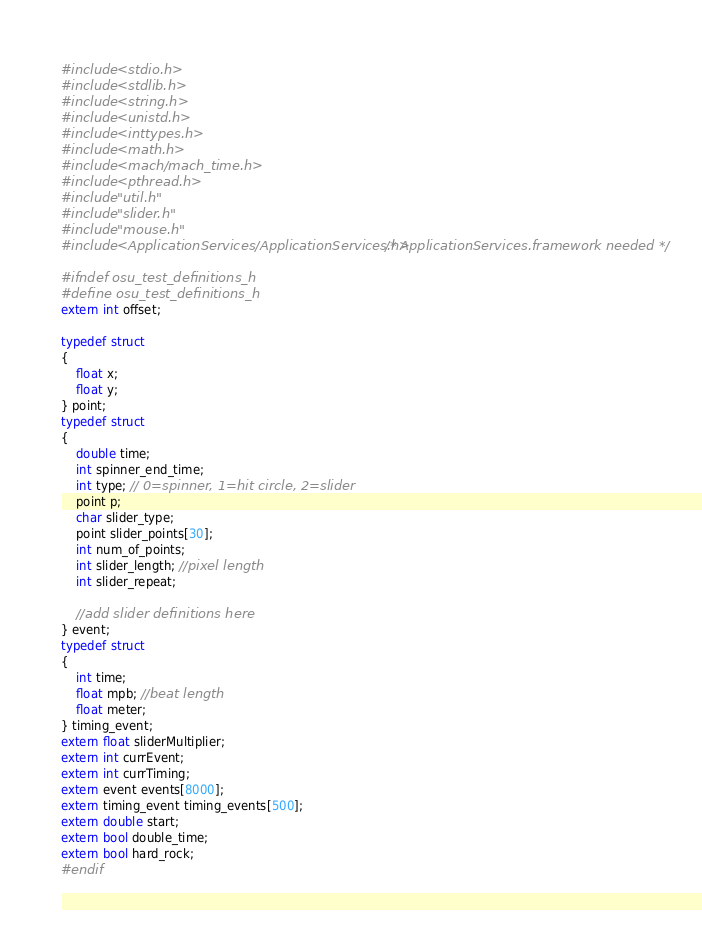Convert code to text. <code><loc_0><loc_0><loc_500><loc_500><_C_>#include <stdio.h>
#include <stdlib.h>
#include <string.h>
#include <unistd.h>
#include <inttypes.h>
#include <math.h>
#include <mach/mach_time.h>
#include <pthread.h>
#include "util.h"
#include "slider.h"
#include "mouse.h"
#include <ApplicationServices/ApplicationServices.h> /* ApplicationServices.framework needed */

#ifndef osu_test_definitions_h
#define osu_test_definitions_h
extern int offset;

typedef struct
{
    float x;
    float y;
} point;
typedef struct
{
    double time;
    int spinner_end_time;
    int type; // 0=spinner, 1=hit circle, 2=slider
    point p;
    char slider_type;
    point slider_points[30];
    int num_of_points;
    int slider_length; //pixel length
    int slider_repeat;
    
    //add slider definitions here
} event;
typedef struct
{
    int time;
    float mpb; //beat length
    float meter;
} timing_event;
extern float sliderMultiplier;
extern int currEvent;
extern int currTiming;
extern event events[8000];
extern timing_event timing_events[500];
extern double start;
extern bool double_time;
extern bool hard_rock;
#endif
</code> 